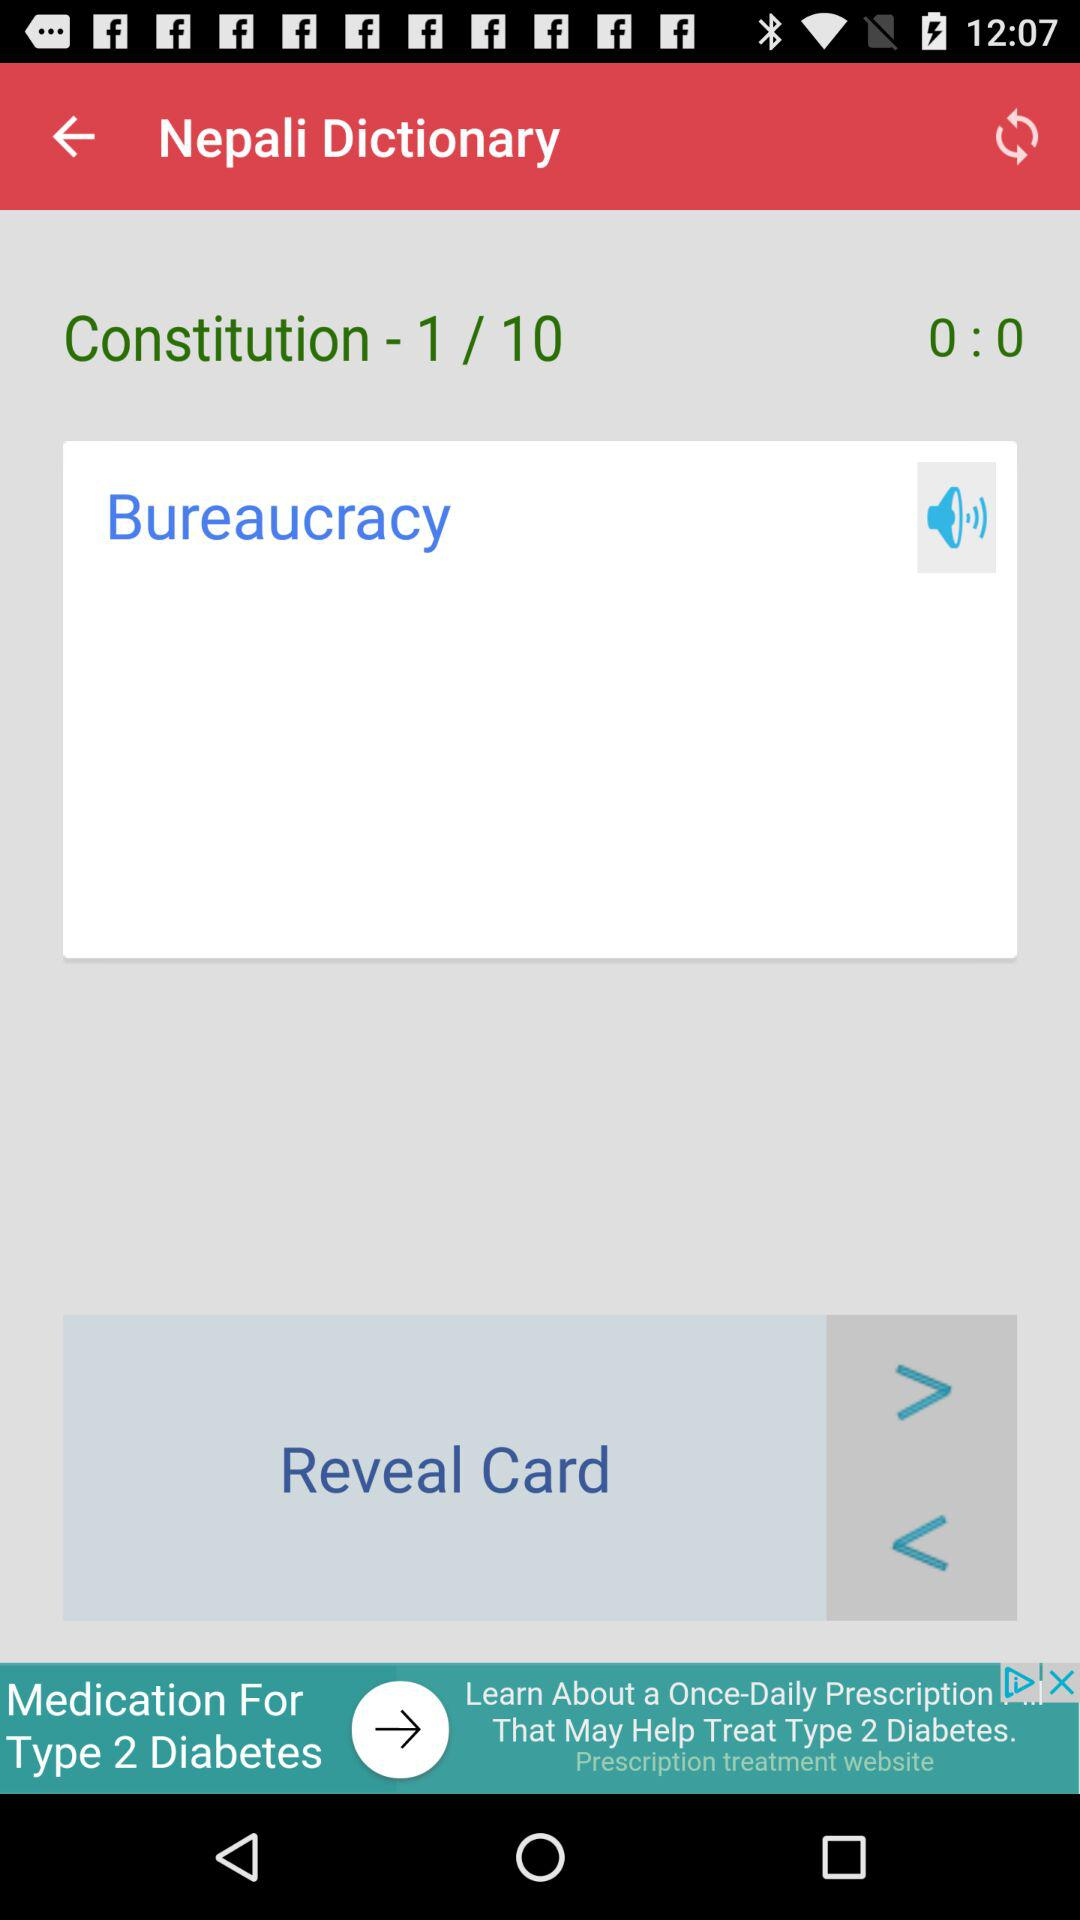What is the word shown in "Nepali Dictionary"? The shown word is "Bureaucracy". 